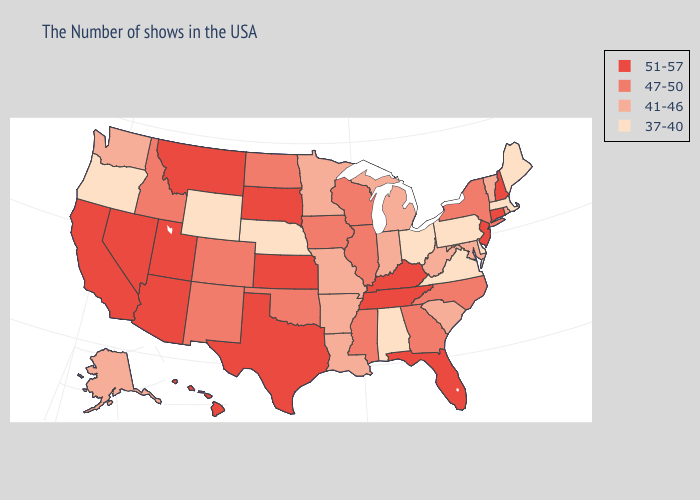Does Kentucky have the highest value in the USA?
Quick response, please. Yes. Among the states that border Missouri , does Kentucky have the lowest value?
Quick response, please. No. Does Iowa have the lowest value in the MidWest?
Answer briefly. No. Does Rhode Island have the lowest value in the Northeast?
Keep it brief. No. What is the highest value in the USA?
Give a very brief answer. 51-57. Does Oregon have the lowest value in the West?
Answer briefly. Yes. Does Kansas have a lower value than Georgia?
Keep it brief. No. Name the states that have a value in the range 37-40?
Give a very brief answer. Maine, Massachusetts, Delaware, Pennsylvania, Virginia, Ohio, Alabama, Nebraska, Wyoming, Oregon. Name the states that have a value in the range 37-40?
Give a very brief answer. Maine, Massachusetts, Delaware, Pennsylvania, Virginia, Ohio, Alabama, Nebraska, Wyoming, Oregon. What is the lowest value in states that border Florida?
Quick response, please. 37-40. Which states have the lowest value in the South?
Quick response, please. Delaware, Virginia, Alabama. What is the lowest value in the USA?
Answer briefly. 37-40. What is the value of Utah?
Answer briefly. 51-57. Name the states that have a value in the range 51-57?
Concise answer only. New Hampshire, Connecticut, New Jersey, Florida, Kentucky, Tennessee, Kansas, Texas, South Dakota, Utah, Montana, Arizona, Nevada, California, Hawaii. Among the states that border North Carolina , which have the lowest value?
Quick response, please. Virginia. 